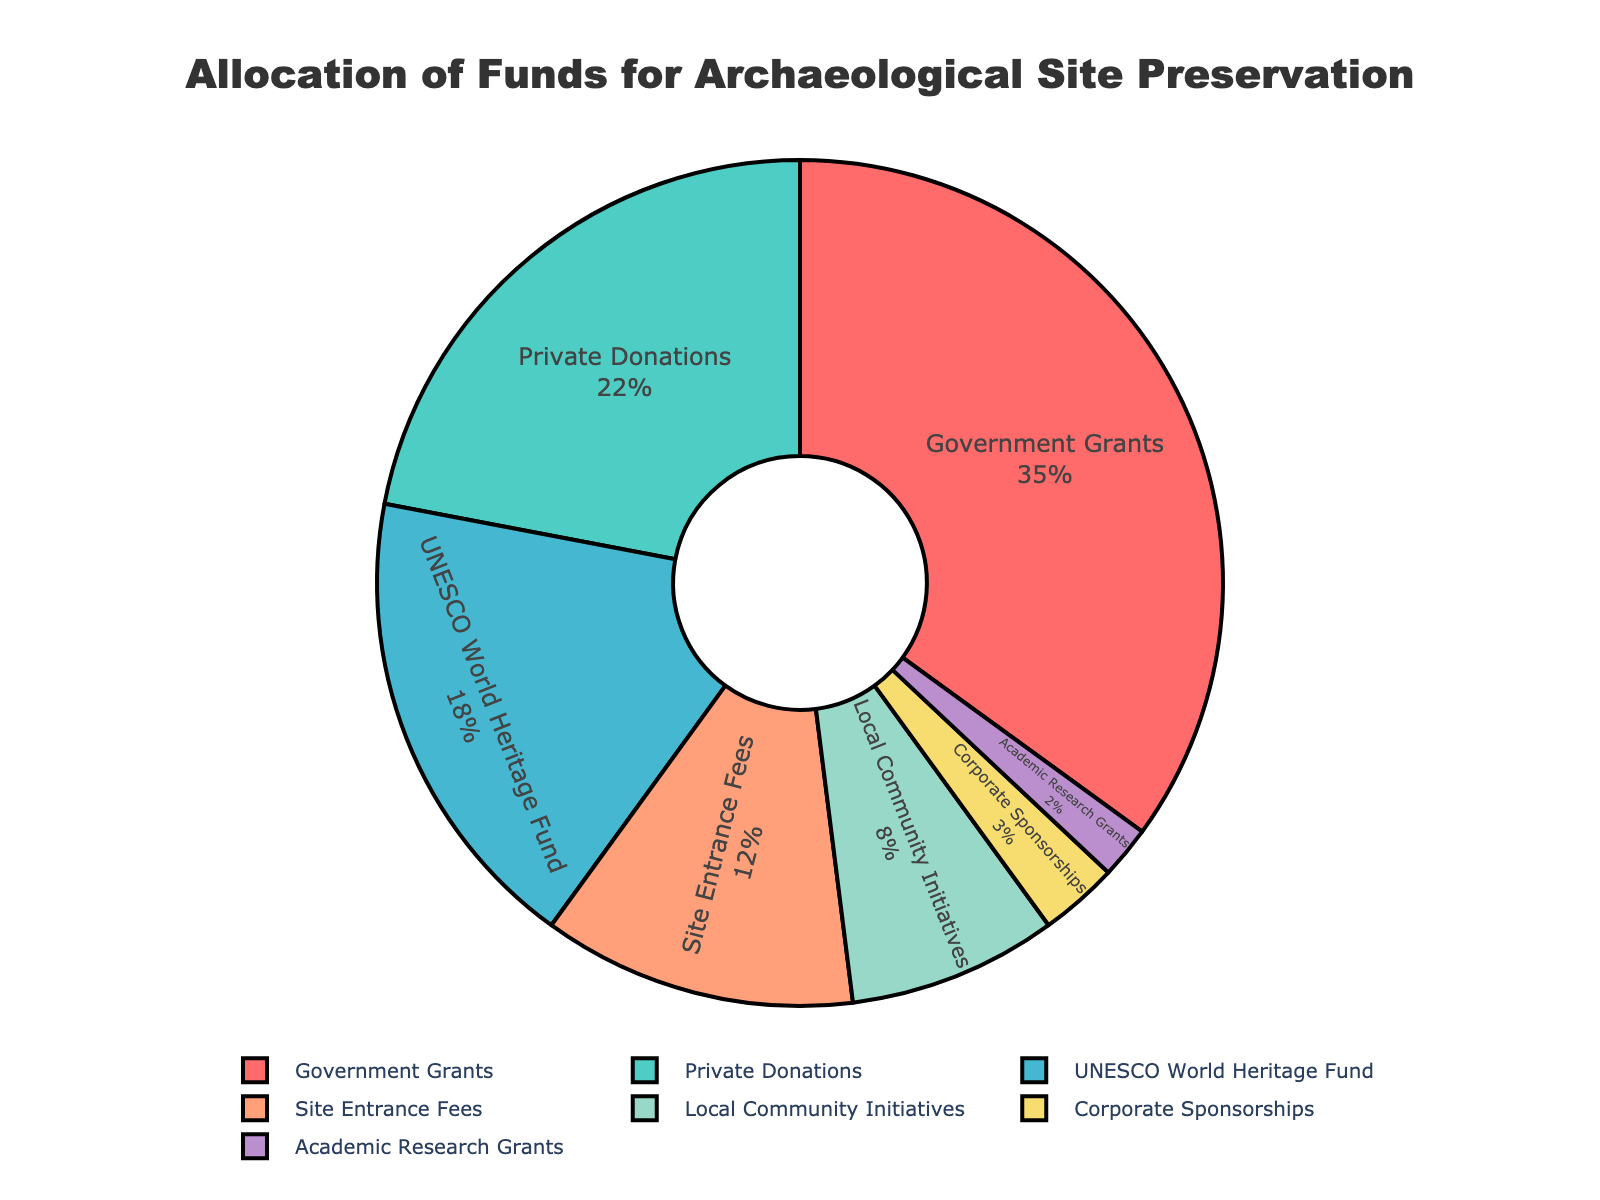Which funding source has the highest percentage allocation? The category with the highest percentage of allocation is visible on the chart as the largest segment.
Answer: Government Grants What is the combined percentage of Private Donations and UNESCO World Heritage Fund? Add the percentages for Private Donations (22%) and UNESCO World Heritage Fund (18%). The combined percentage is 22 + 18.
Answer: 40% How much higher is the percentage allocation for Government Grants compared to Site Entrance Fees? Subtract the percentage for Site Entrance Fees (12%) from the percentage for Government Grants (35%) to find the difference.
Answer: 23% Which category has the smallest allocation percentage? The category with the smallest segment and percentage value on the chart is the one with the smallest allocation.
Answer: Academic Research Grants What is the total percentage for Local Community Initiatives and Corporate Sponsorships? Add the percentages for Local Community Initiatives (8%) and Corporate Sponsorships (3%). The sum is 8 + 3.
Answer: 11% Which funding sources together make up more than half of the total allocation? Add the percentages of the largest categories until the cumulative percentage exceeds 50%. Government Grants (35%) + Private Donations (22%) = 57%.
Answer: Government Grants and Private Donations What percentage of the total allocation is from non-government sources? Subtract the Government Grants percentage (35%) from 100% to find the non-government sources percentage.
Answer: 65% Is the percentage for Site Entrance Fees larger than that for Local Community Initiatives? Compare the percentages for Site Entrance Fees (12%) and Local Community Initiatives (8%). Since 12% is greater than 8%, the answer is yes.
Answer: Yes How does the allocation for Private Donations compare to that for Corporate Sponsorships? Subtract the percentage of Corporate Sponsorships (3%) from Private Donations (22%) to find the difference.
Answer: 19% Which funding source is represented by a green segment? Identify the segment color in the pie chart. The green segment corresponds to the 'Private Donations' category.
Answer: Private Donations 